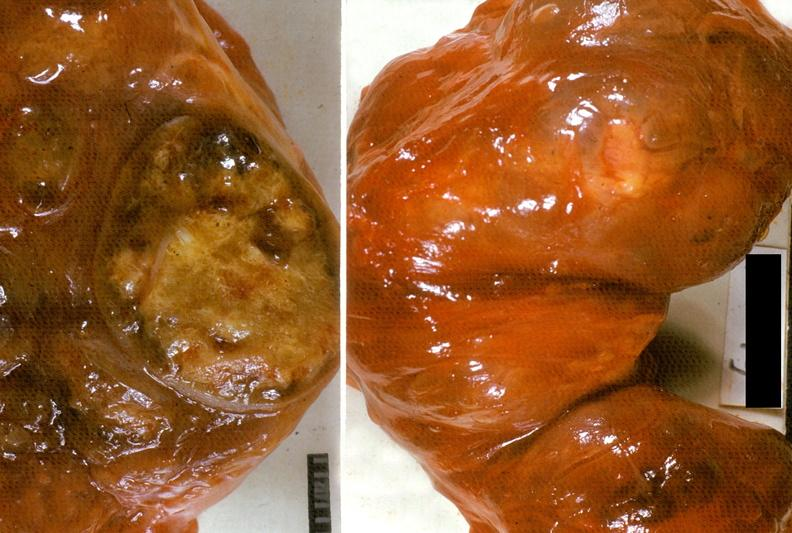s aorta present?
Answer the question using a single word or phrase. No 